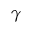Convert formula to latex. <formula><loc_0><loc_0><loc_500><loc_500>\gamma</formula> 